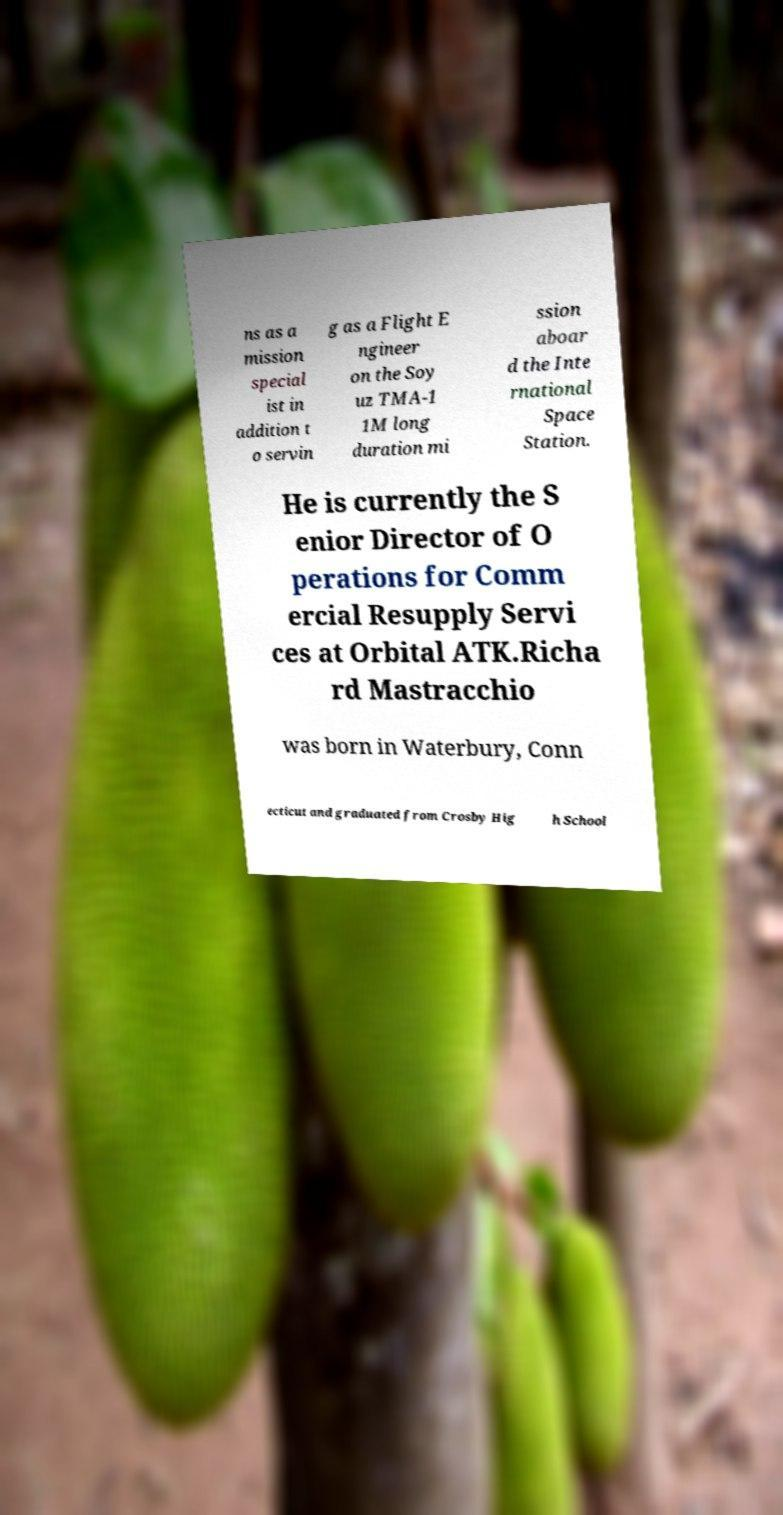What messages or text are displayed in this image? I need them in a readable, typed format. ns as a mission special ist in addition t o servin g as a Flight E ngineer on the Soy uz TMA-1 1M long duration mi ssion aboar d the Inte rnational Space Station. He is currently the S enior Director of O perations for Comm ercial Resupply Servi ces at Orbital ATK.Richa rd Mastracchio was born in Waterbury, Conn ecticut and graduated from Crosby Hig h School 